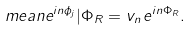<formula> <loc_0><loc_0><loc_500><loc_500>\ m e a n { e ^ { i n \phi _ { j } } | \Phi _ { R } } = v _ { n } \, e ^ { i n \Phi _ { R } } .</formula> 